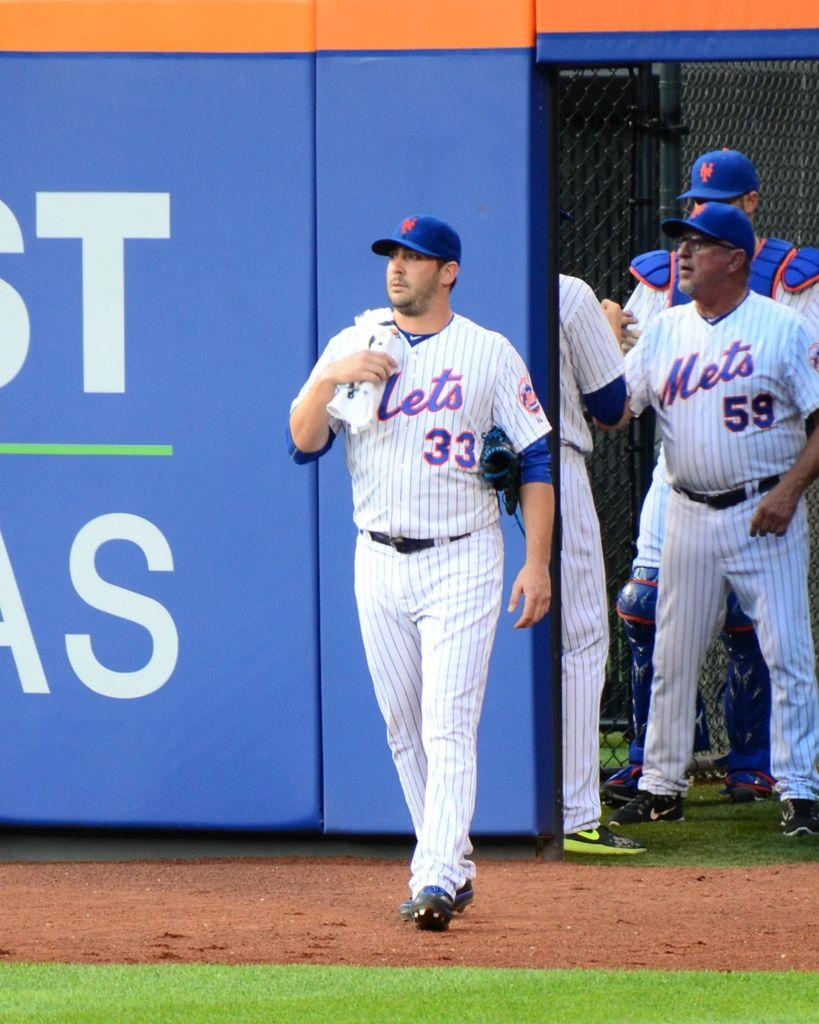<image>
Create a compact narrative representing the image presented. Baseball player wearing number 33 walking onto the grass field. 